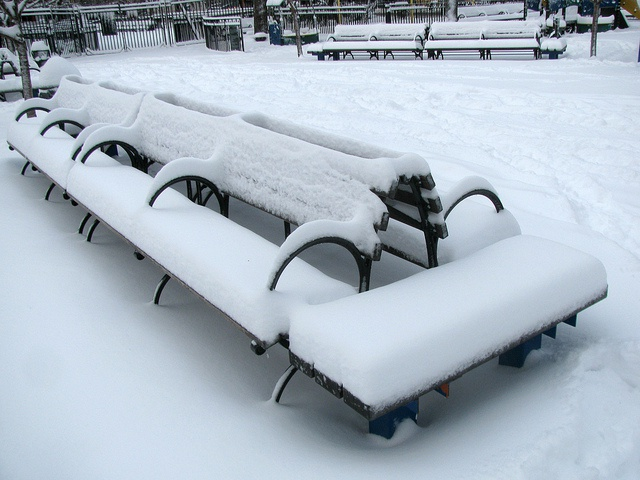Describe the objects in this image and their specific colors. I can see bench in black, lightgray, and darkgray tones, bench in black, lightgray, darkgray, and lightblue tones, and bench in black, lightgray, darkgray, and gray tones in this image. 